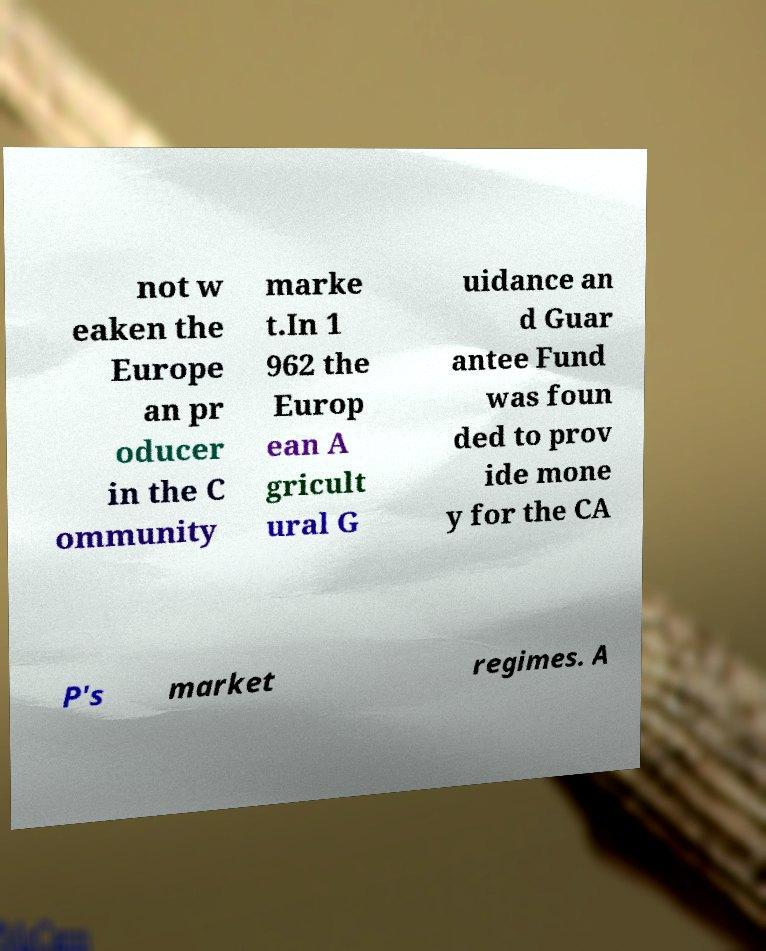What messages or text are displayed in this image? I need them in a readable, typed format. not w eaken the Europe an pr oducer in the C ommunity marke t.In 1 962 the Europ ean A gricult ural G uidance an d Guar antee Fund was foun ded to prov ide mone y for the CA P's market regimes. A 